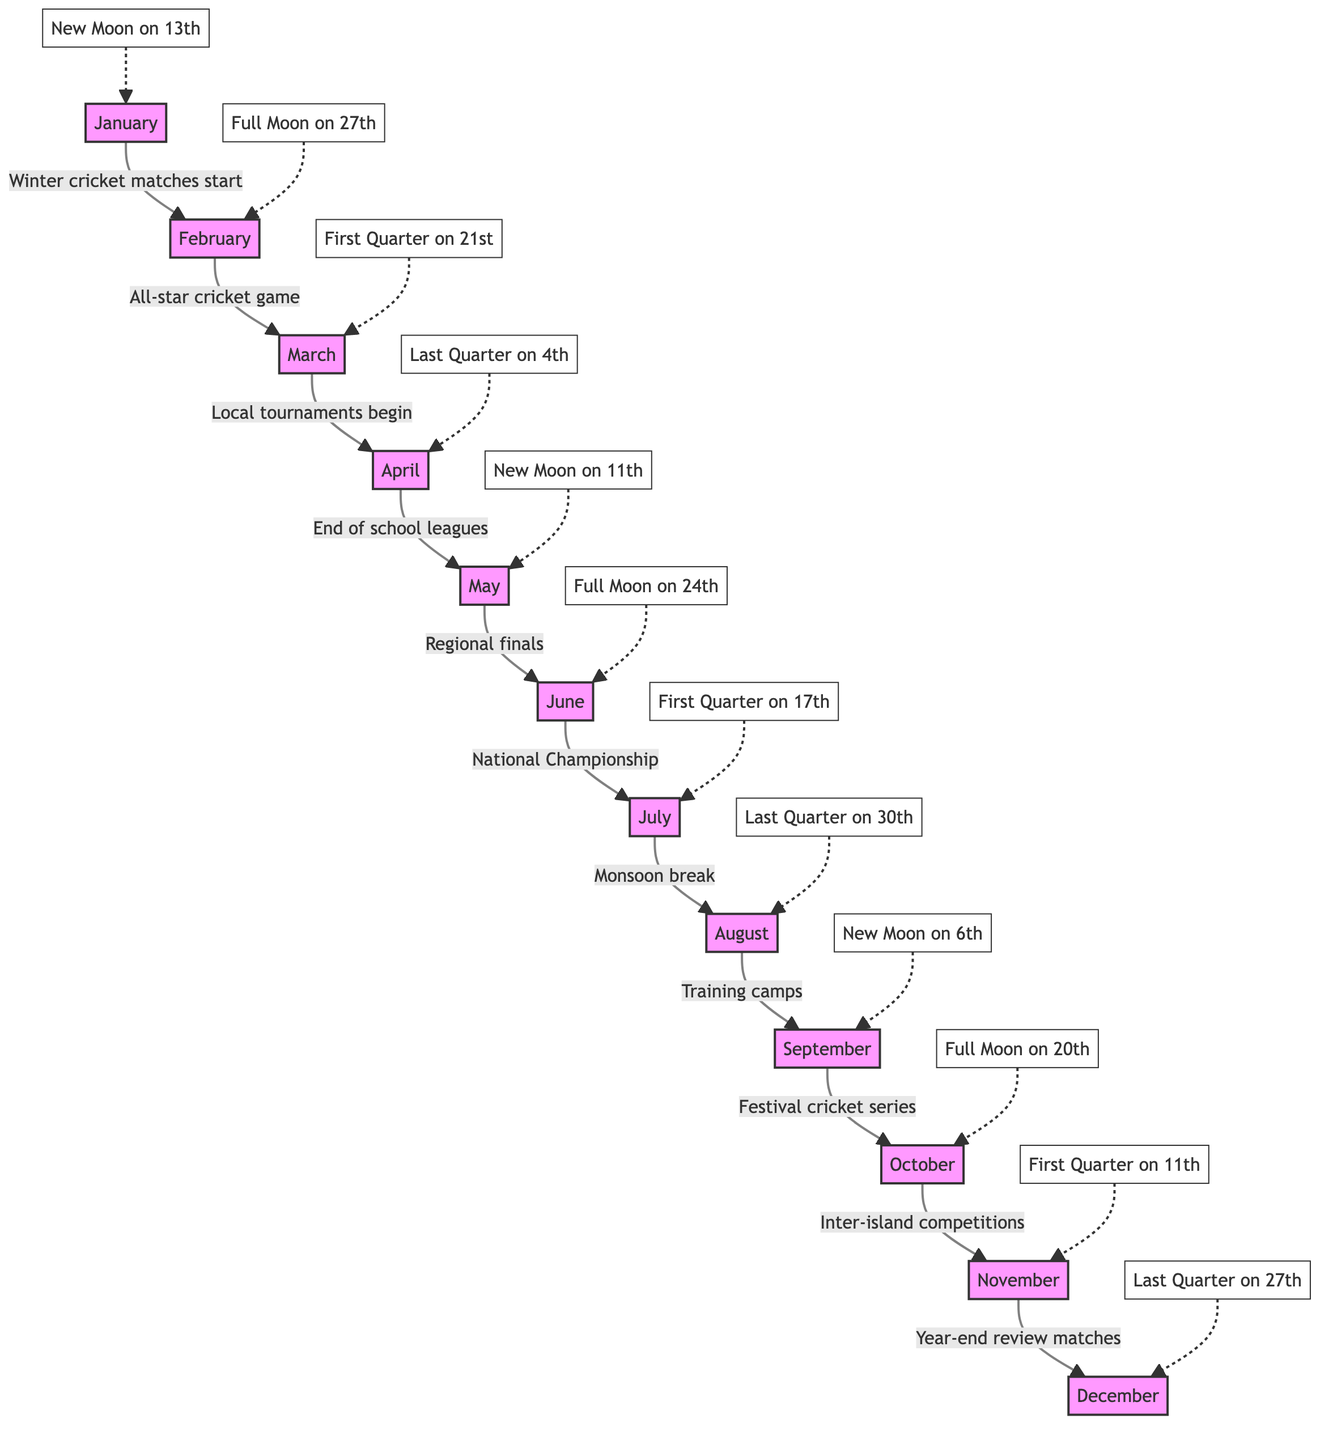What's the moon phase in March? The diagram indicates that March has a First Quarter moon on the 21st, which is noted next to the month node of March.
Answer: First Quarter on 21st How many main cricket events are marked between January and April? Reviewing the diagram, there are four main events from January to April: "Winter cricket matches start," "All-star cricket game," "Local tournaments begin," and "End of school leagues."
Answer: 4 What moon phase occurs in June? According to the diagram, June has a Full Moon on the 24th, which is connected to the month node of June.
Answer: Full Moon on 24th In which month do training camps occur? The diagram specifies that training camps take place in August, reflecting this directly in the layout of events and connections.
Answer: August List the phases of the moon that occur in the second half of the year. From July to December, the phases of the moon are as follows: First Quarter on 17th (July), Last Quarter on 30th (August), New Moon on 6th (September), Full Moon on 20th (October), First Quarter on 11th (November), and Last Quarter on 27th (December).
Answer: First Quarter on 17th, Last Quarter on 30th, New Moon on 6th, Full Moon on 20th, First Quarter on 11th, Last Quarter on 27th What is the relationship between May and the regional finals? The diagram shows an arrow indicating that May is directly connected to the event "Regional finals," which happens in that month. This relationship shows that May is the month designated for this significant cricket event.
Answer: Regional finals How many total months are represented in this diagram? Counting the nodes for each month from January to December, there are a total of 12 months represented in the diagram.
Answer: 12 What event is highlighted immediately after the festival cricket series? The diagram indicates that after the "Festival cricket series" in September, the next event is "Inter-island competitions" in October.
Answer: Inter-island competitions What description fits April in relation to the cricket matches? The flow of the diagram indicates that April is designated for the event "End of school leagues." This highlights the transitional phase in the cricket season.
Answer: End of school leagues 